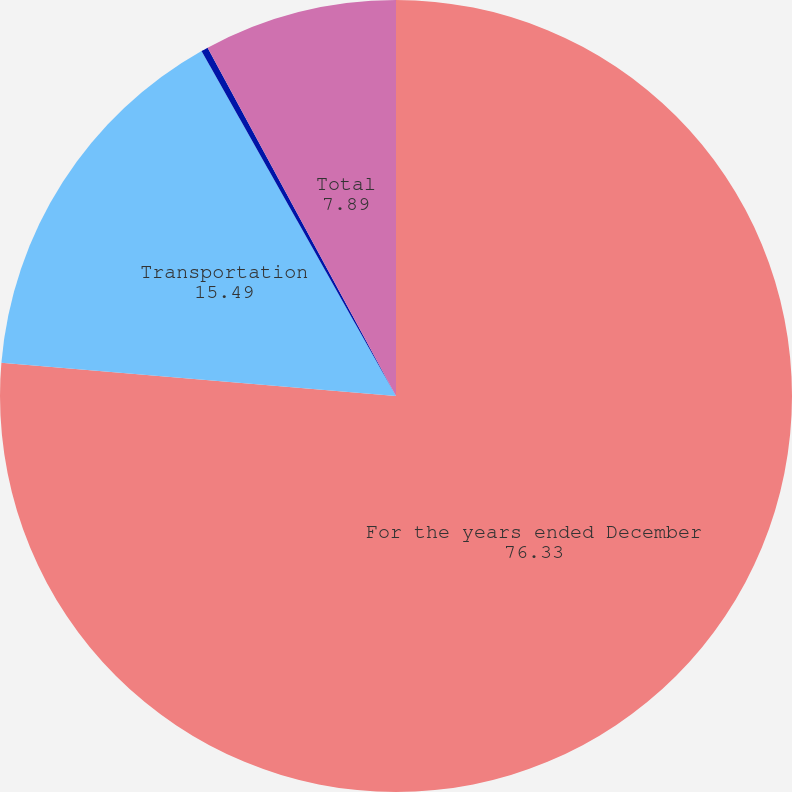<chart> <loc_0><loc_0><loc_500><loc_500><pie_chart><fcel>For the years ended December<fcel>Transportation<fcel>Sourcing<fcel>Total<nl><fcel>76.33%<fcel>15.49%<fcel>0.28%<fcel>7.89%<nl></chart> 